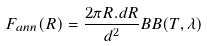Convert formula to latex. <formula><loc_0><loc_0><loc_500><loc_500>F _ { a n n } ( R ) = \frac { 2 \pi R . d R } { d ^ { 2 } } B B ( T , \lambda )</formula> 